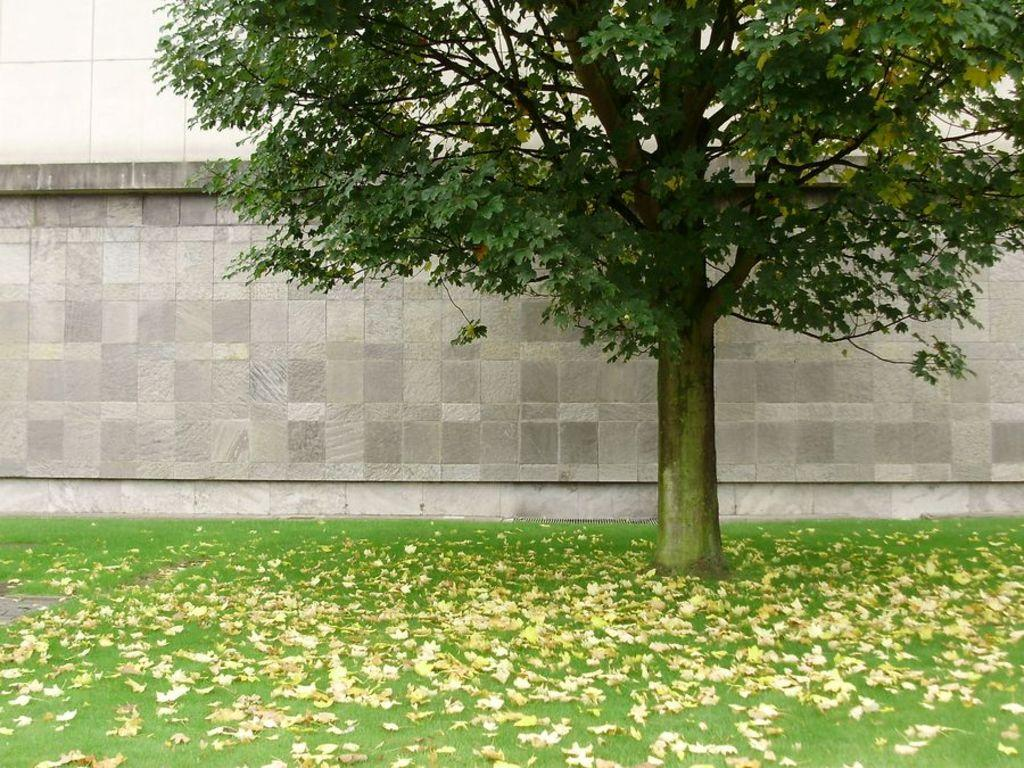What can be seen on the grass in the foreground of the image? There are dry leaves on the grass in the foreground of the image. What is located near the dry leaves on the grass? There is a tree in the foreground of the image. What can be seen in the distance, behind the tree and dry leaves? There is a wall visible in the background of the image. What type of loaf is being kneaded by the grandfather in the image? There is no grandfather or loaf present in the image. How many knees can be seen in the image? There are no knees visible in the image. 